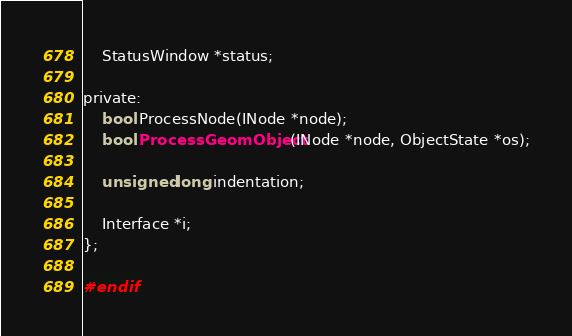<code> <loc_0><loc_0><loc_500><loc_500><_C_>	StatusWindow *status;

private:
	bool ProcessNode(INode *node);
	bool ProcessGeomObject(INode *node, ObjectState *os);

	unsigned long indentation;

	Interface *i;
};

#endif</code> 